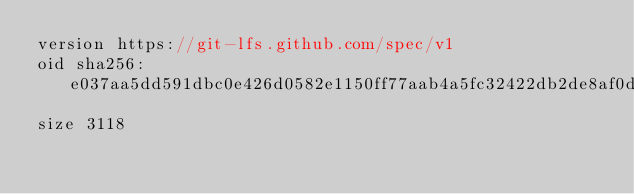Convert code to text. <code><loc_0><loc_0><loc_500><loc_500><_C_>version https://git-lfs.github.com/spec/v1
oid sha256:e037aa5dd591dbc0e426d0582e1150ff77aab4a5fc32422db2de8af0d386ea97
size 3118
</code> 